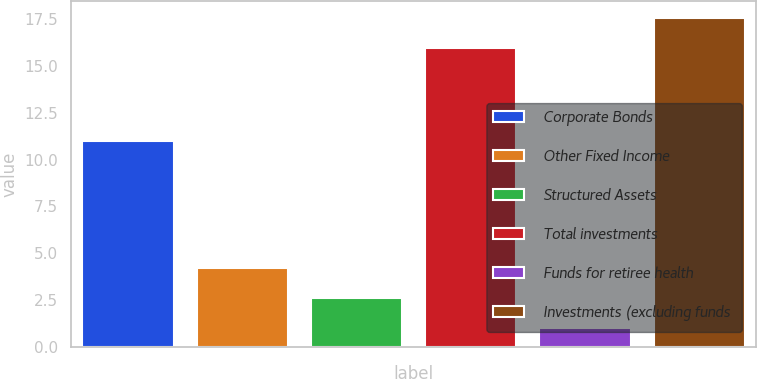Convert chart to OTSL. <chart><loc_0><loc_0><loc_500><loc_500><bar_chart><fcel>Corporate Bonds<fcel>Other Fixed Income<fcel>Structured Assets<fcel>Total investments<fcel>Funds for retiree health<fcel>Investments (excluding funds<nl><fcel>11<fcel>4.2<fcel>2.6<fcel>16<fcel>1<fcel>17.6<nl></chart> 